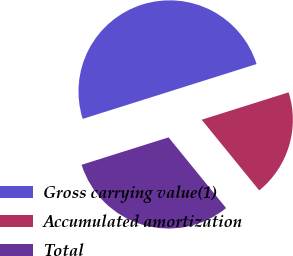Convert chart to OTSL. <chart><loc_0><loc_0><loc_500><loc_500><pie_chart><fcel>Gross carrying value(1)<fcel>Accumulated amortization<fcel>Total<nl><fcel>50.0%<fcel>18.99%<fcel>31.01%<nl></chart> 